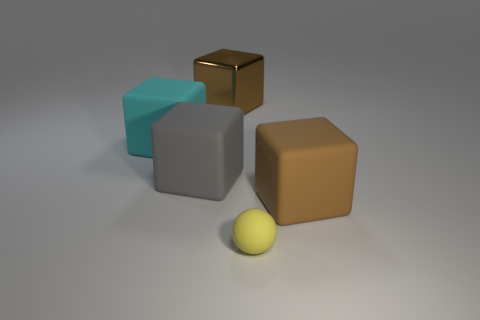There is a large matte object in front of the big gray matte cube; what shape is it?
Provide a short and direct response. Cube. Is the material of the brown block on the right side of the rubber sphere the same as the ball to the right of the big cyan thing?
Provide a succinct answer. Yes. There is a small thing; what shape is it?
Provide a short and direct response. Sphere. Is the number of large blocks that are to the left of the gray rubber cube the same as the number of cyan rubber cubes?
Your answer should be compact. Yes. Are there any brown cubes that have the same material as the yellow object?
Your answer should be compact. Yes. Is the shape of the big brown thing that is left of the small yellow rubber object the same as the tiny yellow object that is right of the cyan matte cube?
Your answer should be very brief. No. Are any gray matte objects visible?
Offer a very short reply. Yes. The metallic cube that is the same size as the gray rubber thing is what color?
Your response must be concise. Brown. How many big metal objects have the same shape as the brown rubber thing?
Keep it short and to the point. 1. Are the object right of the tiny yellow rubber thing and the large gray cube made of the same material?
Your response must be concise. Yes. 